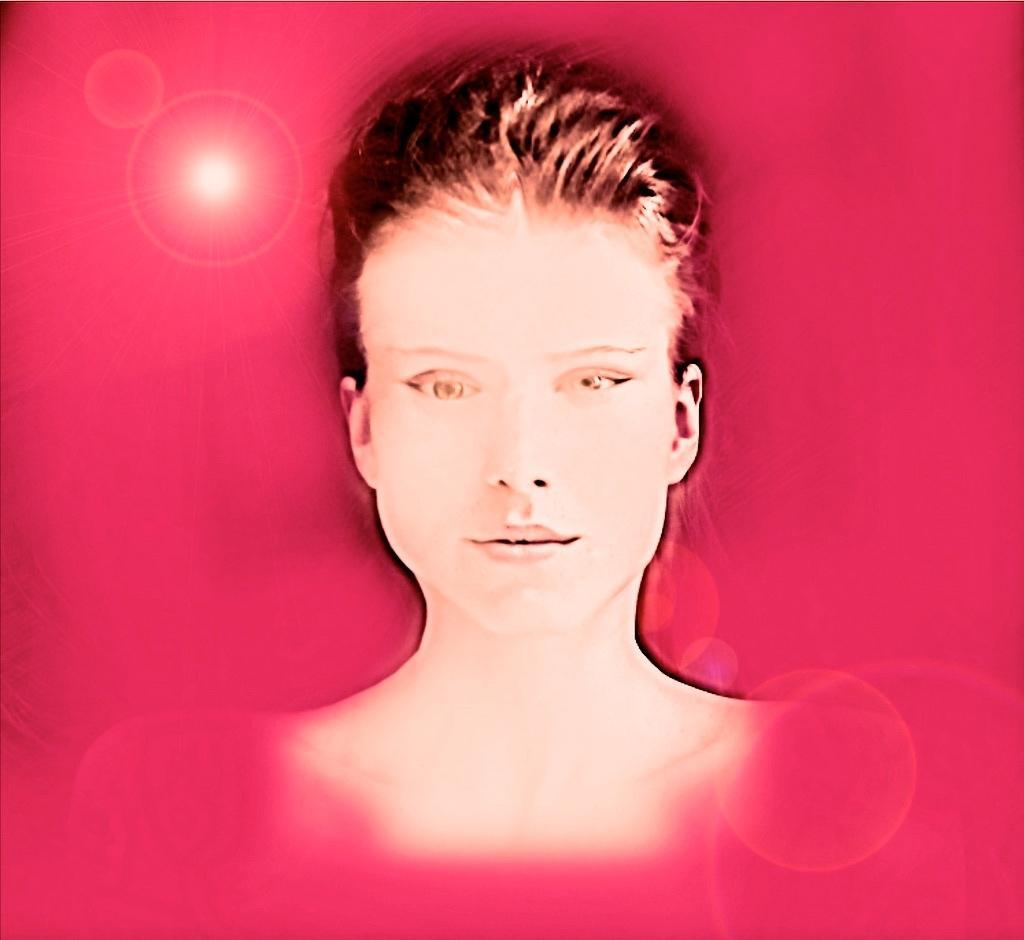How would you summarize this image in a sentence or two? This is an animation, in this image in the center there is one woman and there is a pink color background. 